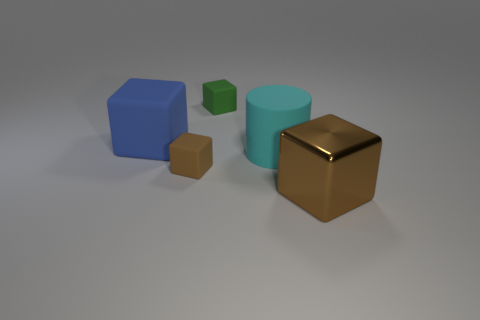Add 4 yellow shiny spheres. How many objects exist? 9 Subtract all cubes. How many objects are left? 1 Subtract 0 purple balls. How many objects are left? 5 Subtract all blue rubber objects. Subtract all big rubber cylinders. How many objects are left? 3 Add 5 small green cubes. How many small green cubes are left? 6 Add 1 tiny cylinders. How many tiny cylinders exist? 1 